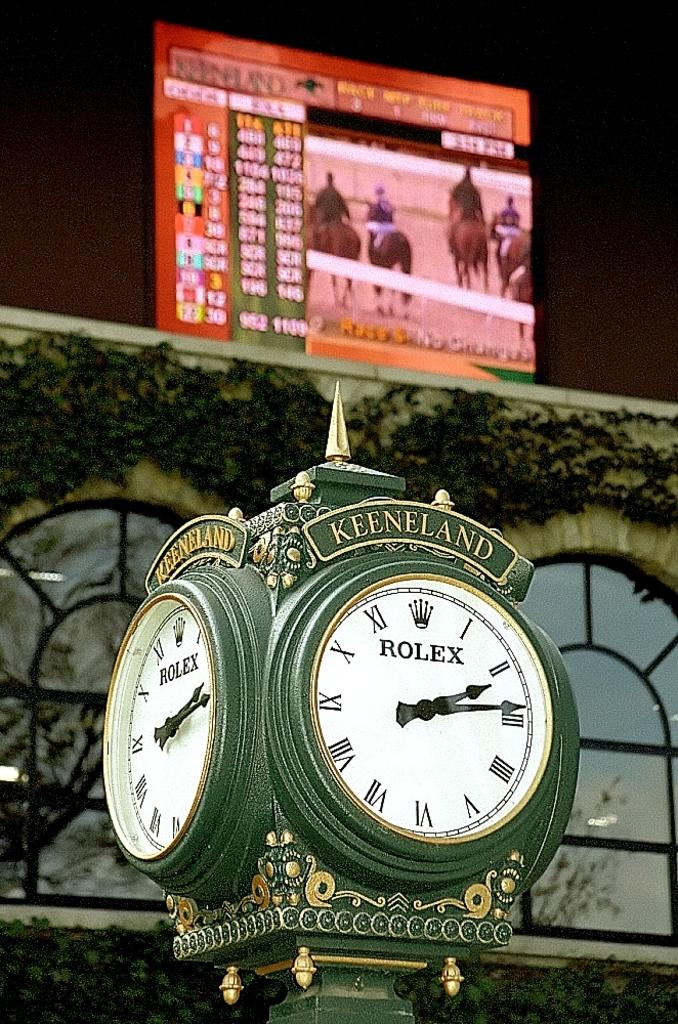<image>
Create a compact narrative representing the image presented. An old looking clock is displayed with the words rolex and keeneland 